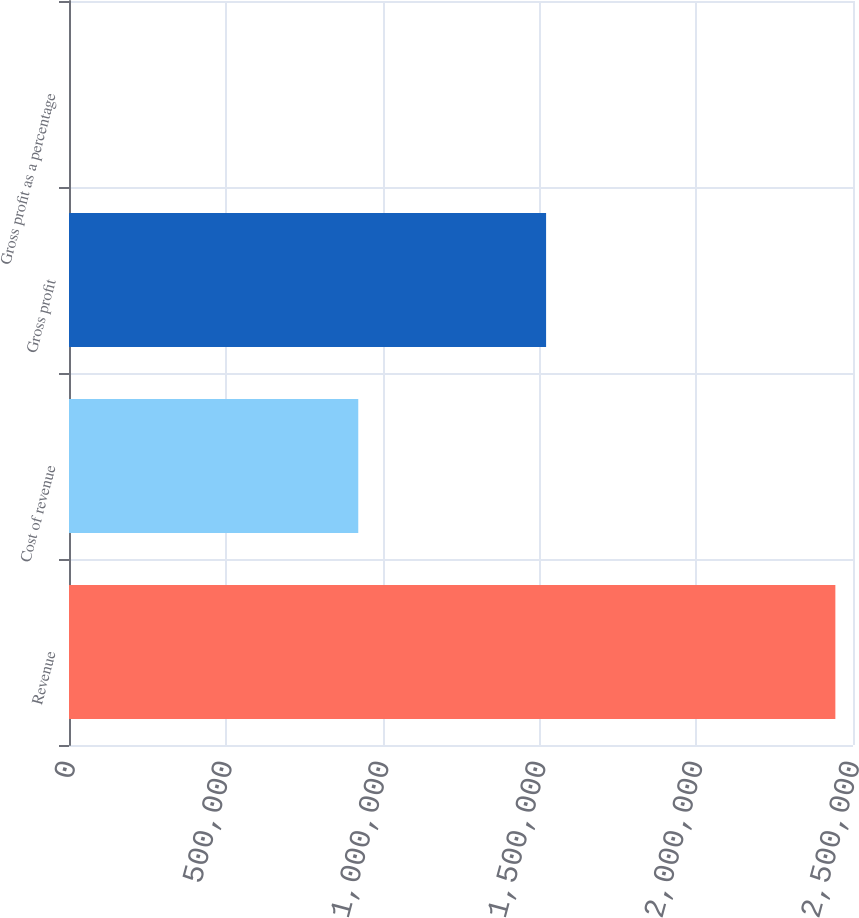Convert chart. <chart><loc_0><loc_0><loc_500><loc_500><bar_chart><fcel>Revenue<fcel>Cost of revenue<fcel>Gross profit<fcel>Gross profit as a percentage<nl><fcel>2.44374e+06<fcel>922414<fcel>1.52133e+06<fcel>62<nl></chart> 